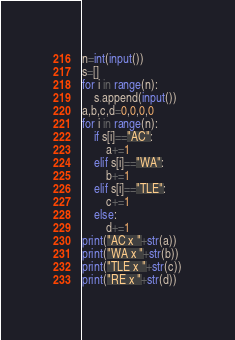<code> <loc_0><loc_0><loc_500><loc_500><_Python_>n=int(input())
s=[]
for i in range(n):
    s.append(input())
a,b,c,d=0,0,0,0
for i in range(n):
    if s[i]=="AC":
        a+=1
    elif s[i]=="WA":
        b+=1
    elif s[i]=="TLE":
        c+=1
    else:
        d+=1
print("AC x "+str(a))
print("WA x "+str(b))
print("TLE x "+str(c))
print("RE x "+str(d))</code> 